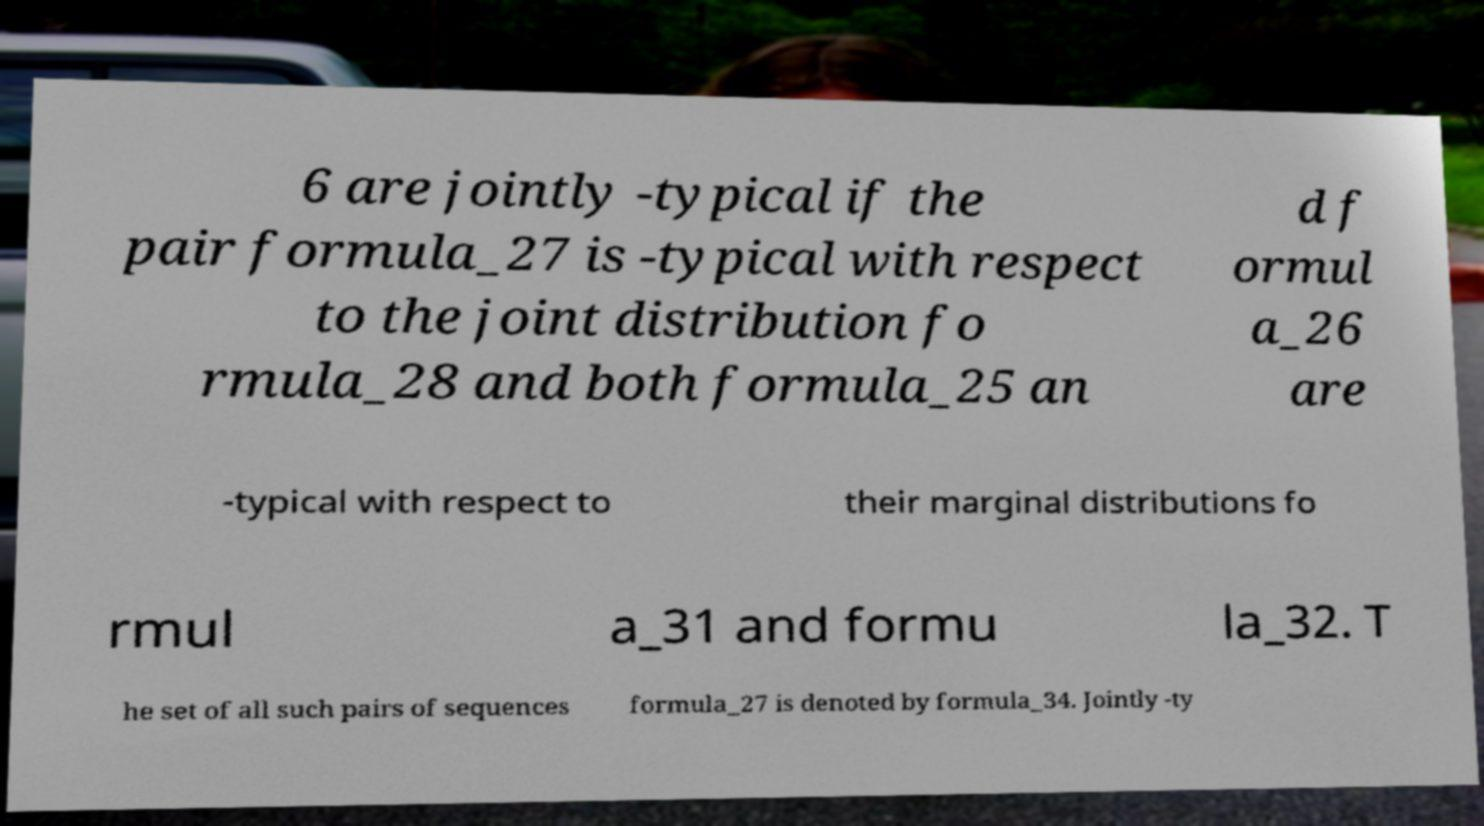Please read and relay the text visible in this image. What does it say? 6 are jointly -typical if the pair formula_27 is -typical with respect to the joint distribution fo rmula_28 and both formula_25 an d f ormul a_26 are -typical with respect to their marginal distributions fo rmul a_31 and formu la_32. T he set of all such pairs of sequences formula_27 is denoted by formula_34. Jointly -ty 